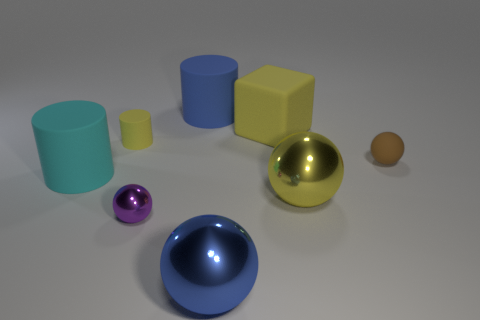There is a metal ball that is behind the purple metallic object; what is its color?
Offer a terse response. Yellow. How many tiny rubber cylinders are the same color as the small shiny ball?
Make the answer very short. 0. Are there fewer big balls behind the blue shiny thing than small brown matte objects on the left side of the tiny brown ball?
Provide a succinct answer. No. There is a blue metallic thing; what number of large metallic spheres are behind it?
Provide a succinct answer. 1. Are there any big gray blocks made of the same material as the purple thing?
Offer a very short reply. No. Is the number of small objects behind the brown matte thing greater than the number of small cylinders in front of the cyan matte cylinder?
Offer a very short reply. Yes. The cyan rubber cylinder has what size?
Your answer should be very brief. Large. What is the shape of the big rubber thing that is in front of the small brown object?
Give a very brief answer. Cylinder. Do the large yellow rubber object and the blue rubber thing have the same shape?
Your answer should be very brief. No. Are there the same number of cyan rubber cylinders that are to the right of the small purple shiny ball and large red things?
Your response must be concise. Yes. 